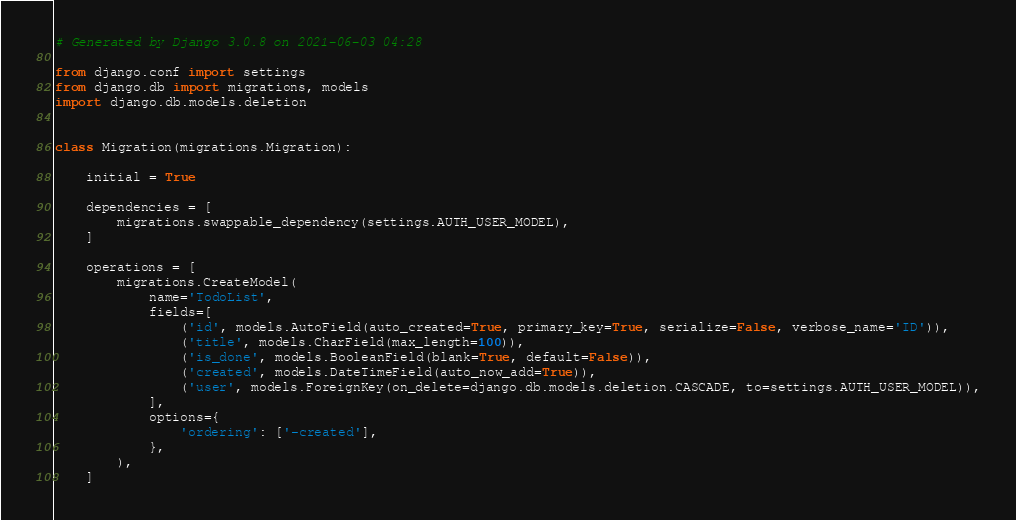<code> <loc_0><loc_0><loc_500><loc_500><_Python_># Generated by Django 3.0.8 on 2021-06-03 04:28

from django.conf import settings
from django.db import migrations, models
import django.db.models.deletion


class Migration(migrations.Migration):

    initial = True

    dependencies = [
        migrations.swappable_dependency(settings.AUTH_USER_MODEL),
    ]

    operations = [
        migrations.CreateModel(
            name='TodoList',
            fields=[
                ('id', models.AutoField(auto_created=True, primary_key=True, serialize=False, verbose_name='ID')),
                ('title', models.CharField(max_length=100)),
                ('is_done', models.BooleanField(blank=True, default=False)),
                ('created', models.DateTimeField(auto_now_add=True)),
                ('user', models.ForeignKey(on_delete=django.db.models.deletion.CASCADE, to=settings.AUTH_USER_MODEL)),
            ],
            options={
                'ordering': ['-created'],
            },
        ),
    ]
</code> 